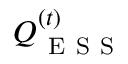Convert formula to latex. <formula><loc_0><loc_0><loc_500><loc_500>Q _ { E S S } ^ { ( t ) }</formula> 